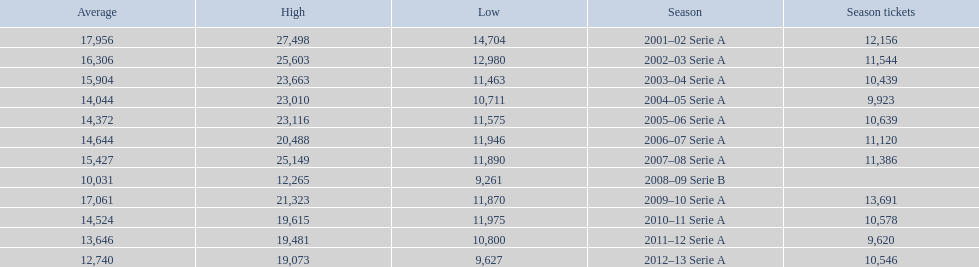What was the average in 2001 17,956. 